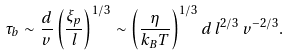<formula> <loc_0><loc_0><loc_500><loc_500>\tau _ { b } \sim \frac { d } { v } \left ( \frac { \xi _ { p } } { l } \right ) ^ { 1 / 3 } \sim \left ( \frac { \eta } { k _ { B } T } \right ) ^ { 1 / 3 } d \, l ^ { 2 / 3 } \, v ^ { - 2 / 3 } .</formula> 